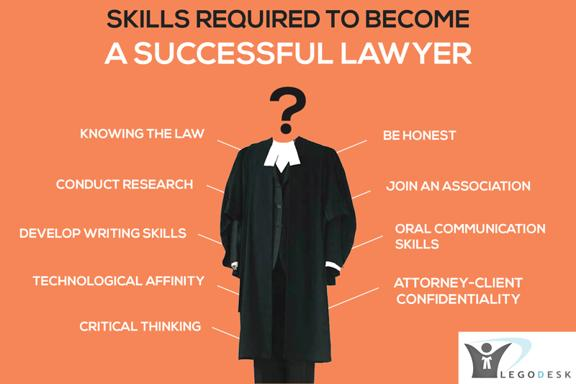What are some skills required to become a successful lawyer mentioned in the image? According to the image, the essential skills for becoming a successful lawyer include a deep understanding of the law, a steadfast commitment to honesty, strong research capabilities, proficiency in written and oral communication, a knack for technology, and an unshakeable dedication to maintaining attorney-client confidentiality. These skills are foundational to navigating the complexities of legal cases and upholding justice. 